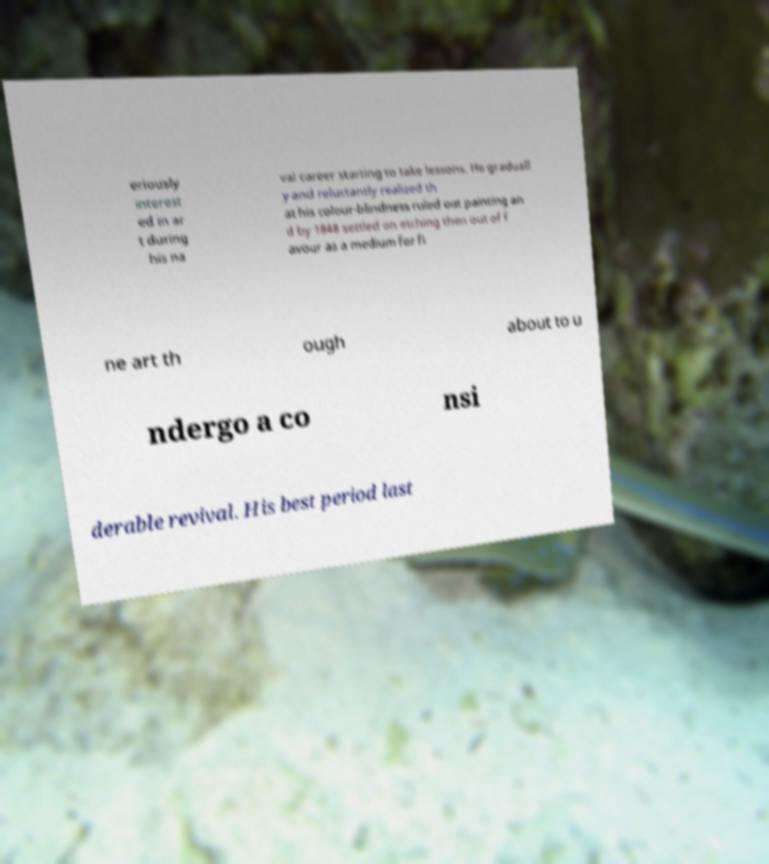Please identify and transcribe the text found in this image. eriously interest ed in ar t during his na val career starting to take lessons. He graduall y and reluctantly realized th at his colour-blindness ruled out painting an d by 1848 settled on etching then out of f avour as a medium for fi ne art th ough about to u ndergo a co nsi derable revival. His best period last 